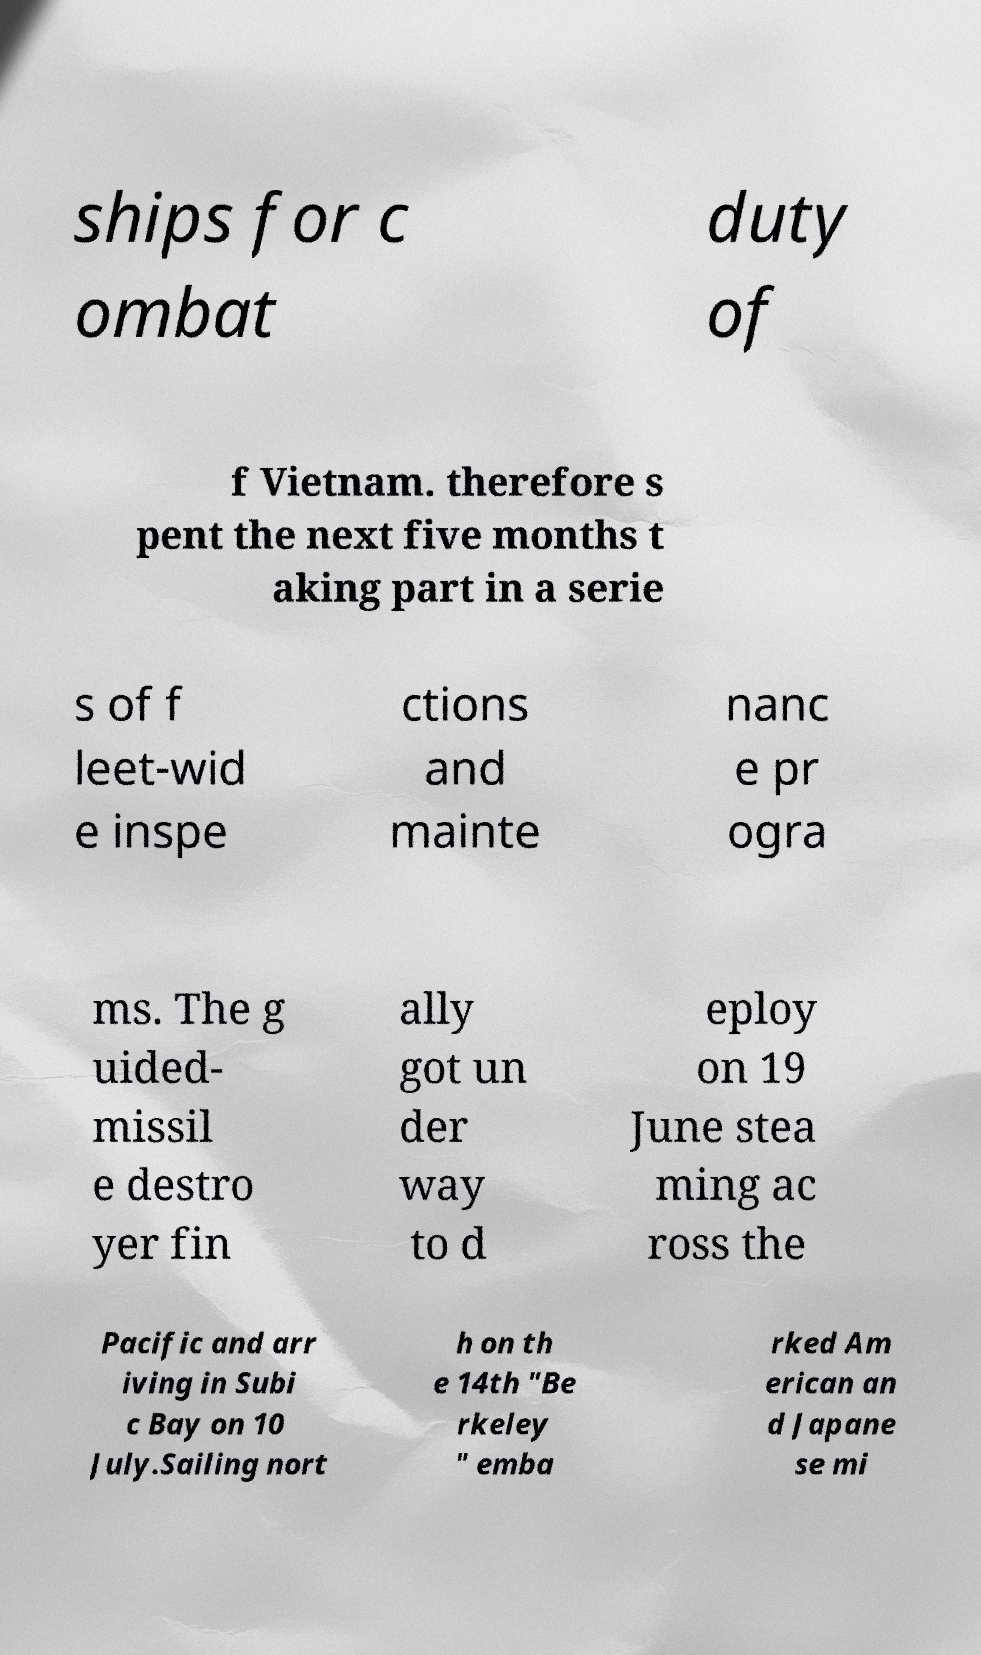Please read and relay the text visible in this image. What does it say? ships for c ombat duty of f Vietnam. therefore s pent the next five months t aking part in a serie s of f leet-wid e inspe ctions and mainte nanc e pr ogra ms. The g uided- missil e destro yer fin ally got un der way to d eploy on 19 June stea ming ac ross the Pacific and arr iving in Subi c Bay on 10 July.Sailing nort h on th e 14th "Be rkeley " emba rked Am erican an d Japane se mi 